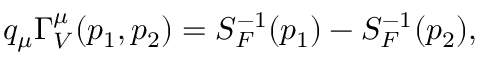Convert formula to latex. <formula><loc_0><loc_0><loc_500><loc_500>q _ { \mu } \Gamma _ { V } ^ { \mu } ( p _ { 1 } , p _ { 2 } ) = S _ { F } ^ { - 1 } ( p _ { 1 } ) - S _ { F } ^ { - 1 } ( p _ { 2 } ) ,</formula> 